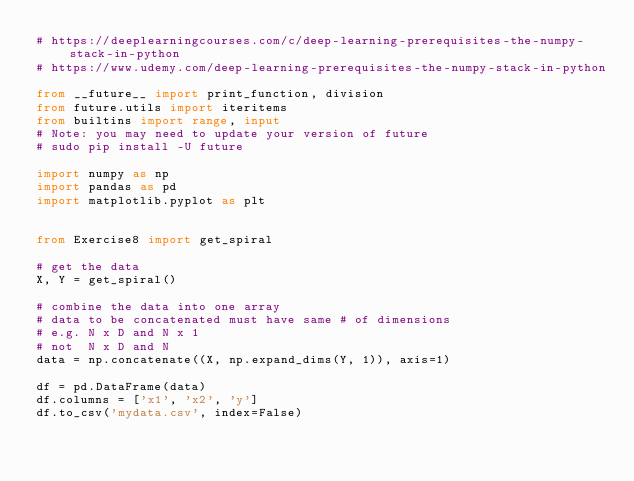Convert code to text. <code><loc_0><loc_0><loc_500><loc_500><_Python_># https://deeplearningcourses.com/c/deep-learning-prerequisites-the-numpy-stack-in-python
# https://www.udemy.com/deep-learning-prerequisites-the-numpy-stack-in-python

from __future__ import print_function, division
from future.utils import iteritems
from builtins import range, input
# Note: you may need to update your version of future
# sudo pip install -U future

import numpy as np
import pandas as pd
import matplotlib.pyplot as plt


from Exercise8 import get_spiral

# get the data
X, Y = get_spiral()

# combine the data into one array
# data to be concatenated must have same # of dimensions
# e.g. N x D and N x 1
# not  N x D and N
data = np.concatenate((X, np.expand_dims(Y, 1)), axis=1)

df = pd.DataFrame(data)
df.columns = ['x1', 'x2', 'y']
df.to_csv('mydata.csv', index=False)</code> 